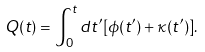Convert formula to latex. <formula><loc_0><loc_0><loc_500><loc_500>Q ( t ) = \int _ { 0 } ^ { t } d t ^ { \prime } [ \phi ( t ^ { \prime } ) + \kappa ( t ^ { \prime } ) ] .</formula> 